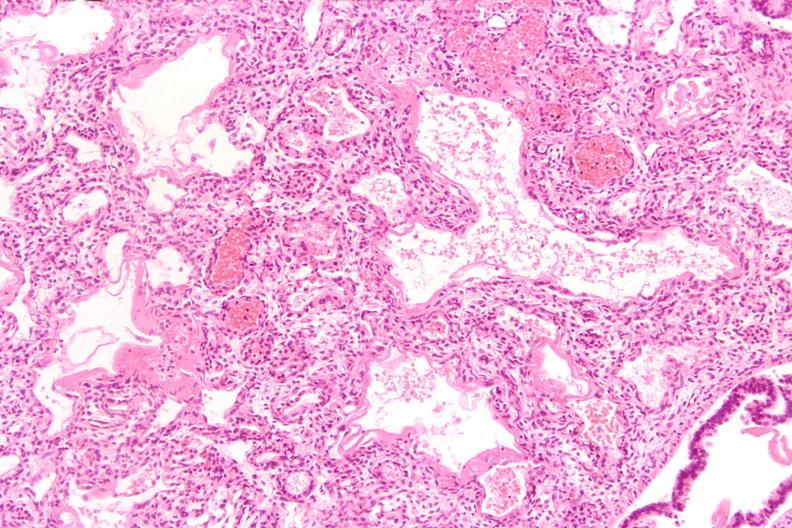does this image show lungs, hyaline membrane disease?
Answer the question using a single word or phrase. Yes 